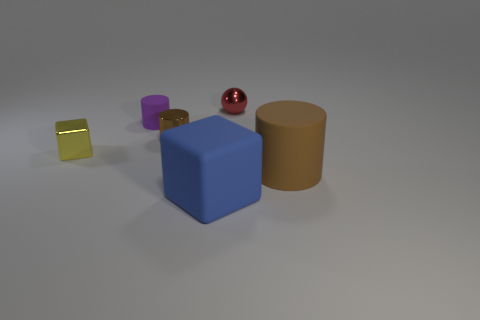There is a red object behind the yellow thing; does it have the same shape as the large blue matte thing? no 